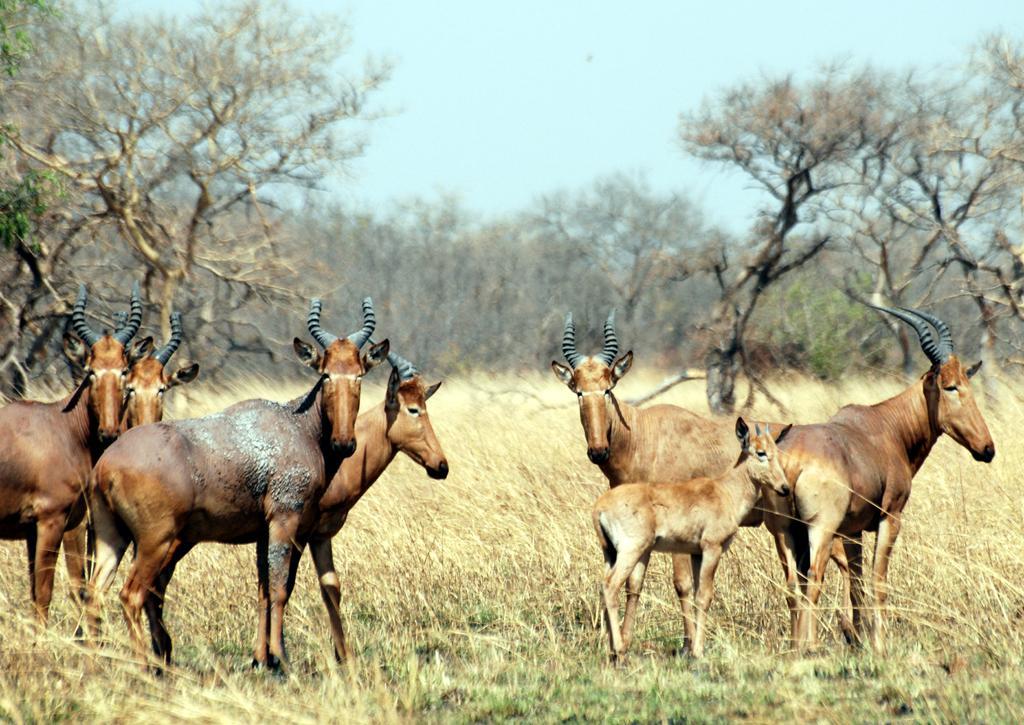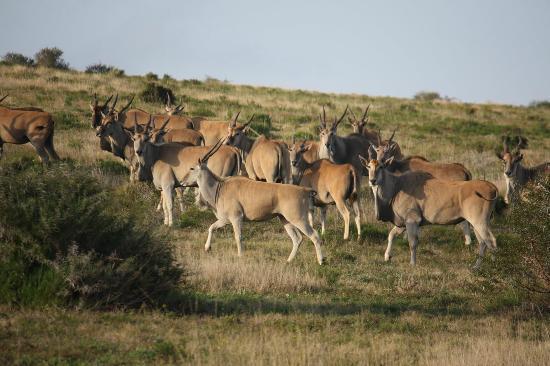The first image is the image on the left, the second image is the image on the right. Analyze the images presented: Is the assertion "There are no more than seven animals in the image on the left." valid? Answer yes or no. Yes. 